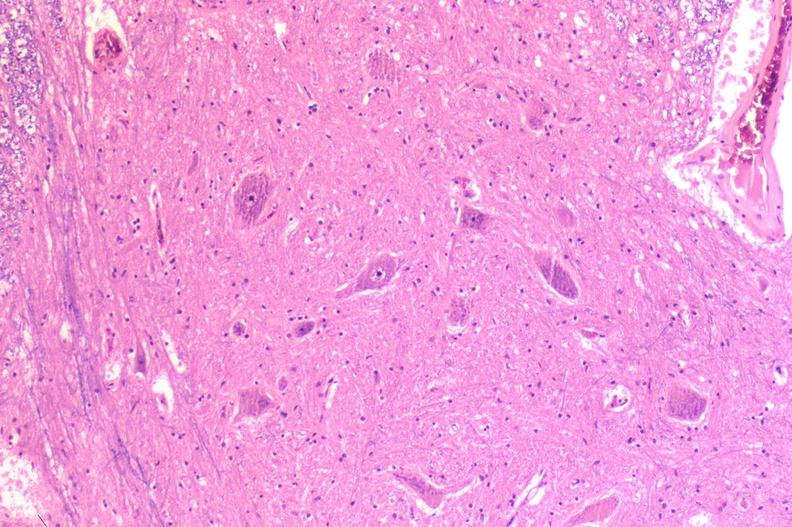does side show spinal cord injury due to vertebral column trauma, demyelination?
Answer the question using a single word or phrase. No 